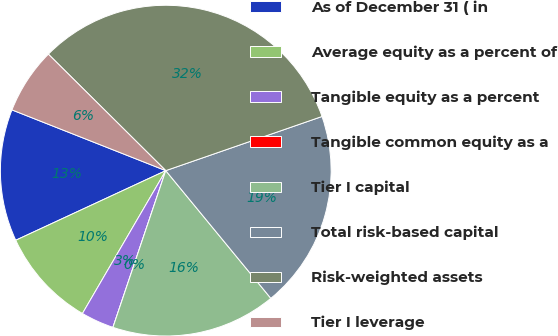Convert chart to OTSL. <chart><loc_0><loc_0><loc_500><loc_500><pie_chart><fcel>As of December 31 ( in<fcel>Average equity as a percent of<fcel>Tangible equity as a percent<fcel>Tangible common equity as a<fcel>Tier I capital<fcel>Total risk-based capital<fcel>Risk-weighted assets<fcel>Tier I leverage<nl><fcel>12.9%<fcel>9.68%<fcel>3.23%<fcel>0.0%<fcel>16.13%<fcel>19.35%<fcel>32.25%<fcel>6.45%<nl></chart> 